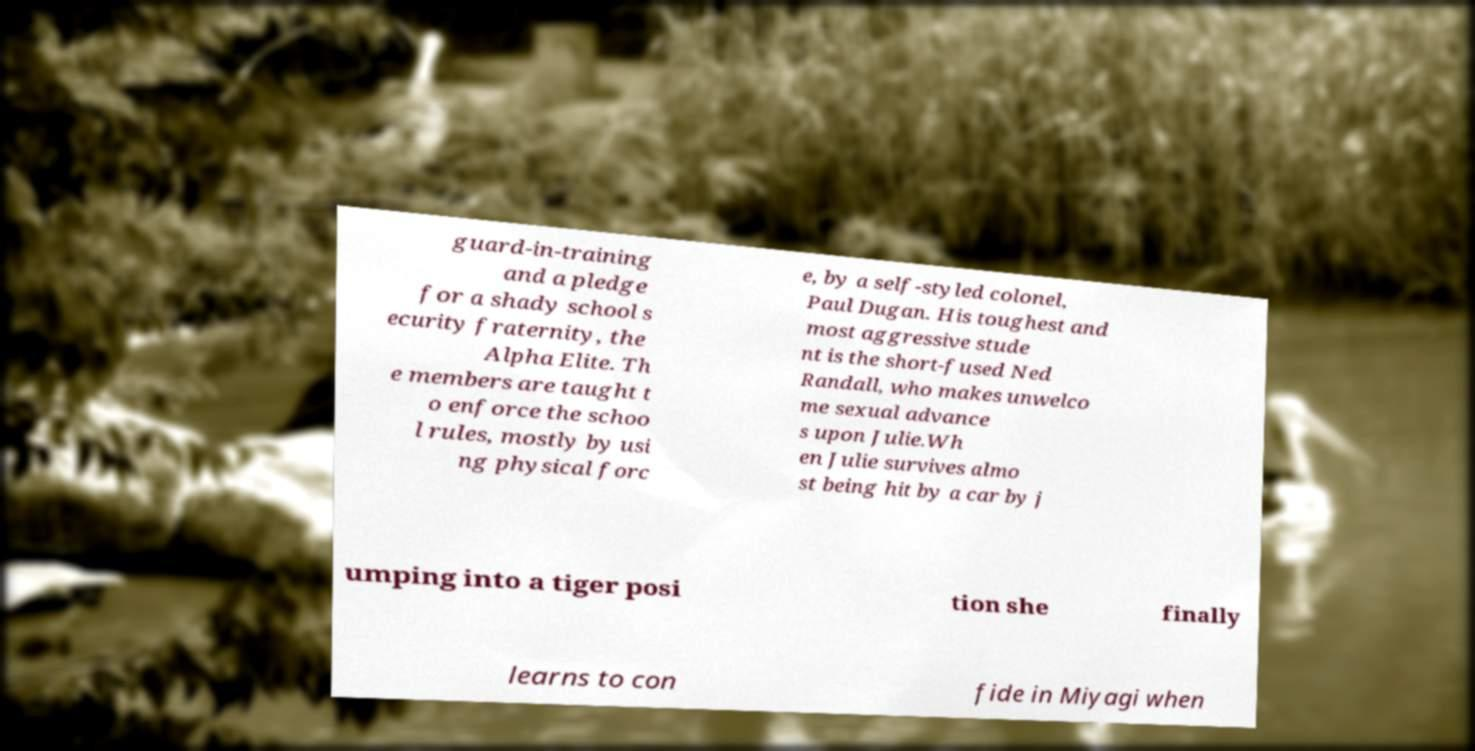Can you accurately transcribe the text from the provided image for me? guard-in-training and a pledge for a shady school s ecurity fraternity, the Alpha Elite. Th e members are taught t o enforce the schoo l rules, mostly by usi ng physical forc e, by a self-styled colonel, Paul Dugan. His toughest and most aggressive stude nt is the short-fused Ned Randall, who makes unwelco me sexual advance s upon Julie.Wh en Julie survives almo st being hit by a car by j umping into a tiger posi tion she finally learns to con fide in Miyagi when 